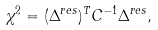<formula> <loc_0><loc_0><loc_500><loc_500>\chi ^ { 2 } = ( \Delta ^ { r e s } ) ^ { T } C ^ { - 1 } \Delta ^ { r e s } ,</formula> 